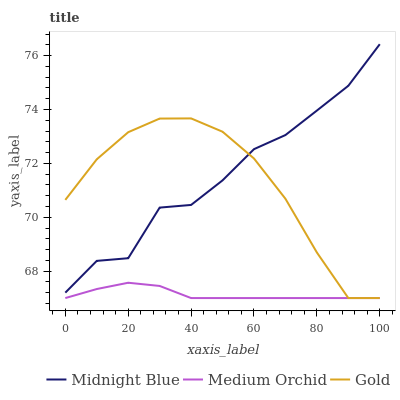Does Medium Orchid have the minimum area under the curve?
Answer yes or no. Yes. Does Midnight Blue have the maximum area under the curve?
Answer yes or no. Yes. Does Gold have the minimum area under the curve?
Answer yes or no. No. Does Gold have the maximum area under the curve?
Answer yes or no. No. Is Medium Orchid the smoothest?
Answer yes or no. Yes. Is Midnight Blue the roughest?
Answer yes or no. Yes. Is Gold the smoothest?
Answer yes or no. No. Is Gold the roughest?
Answer yes or no. No. Does Medium Orchid have the lowest value?
Answer yes or no. Yes. Does Midnight Blue have the lowest value?
Answer yes or no. No. Does Midnight Blue have the highest value?
Answer yes or no. Yes. Does Gold have the highest value?
Answer yes or no. No. Is Medium Orchid less than Midnight Blue?
Answer yes or no. Yes. Is Midnight Blue greater than Medium Orchid?
Answer yes or no. Yes. Does Gold intersect Midnight Blue?
Answer yes or no. Yes. Is Gold less than Midnight Blue?
Answer yes or no. No. Is Gold greater than Midnight Blue?
Answer yes or no. No. Does Medium Orchid intersect Midnight Blue?
Answer yes or no. No. 